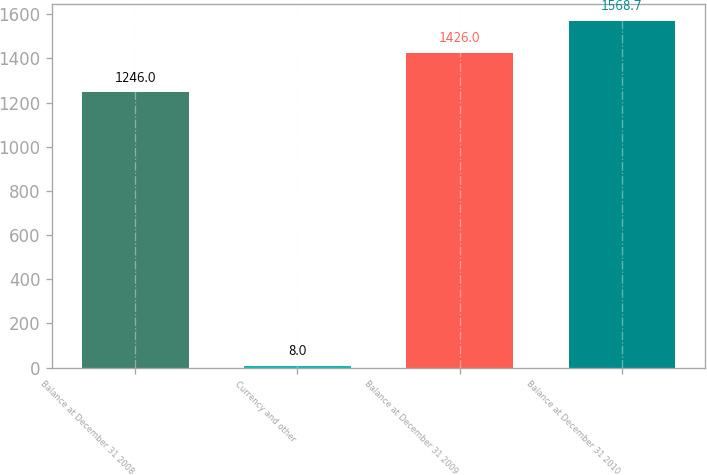<chart> <loc_0><loc_0><loc_500><loc_500><bar_chart><fcel>Balance at December 31 2008<fcel>Currency and other<fcel>Balance at December 31 2009<fcel>Balance at December 31 2010<nl><fcel>1246<fcel>8<fcel>1426<fcel>1568.7<nl></chart> 